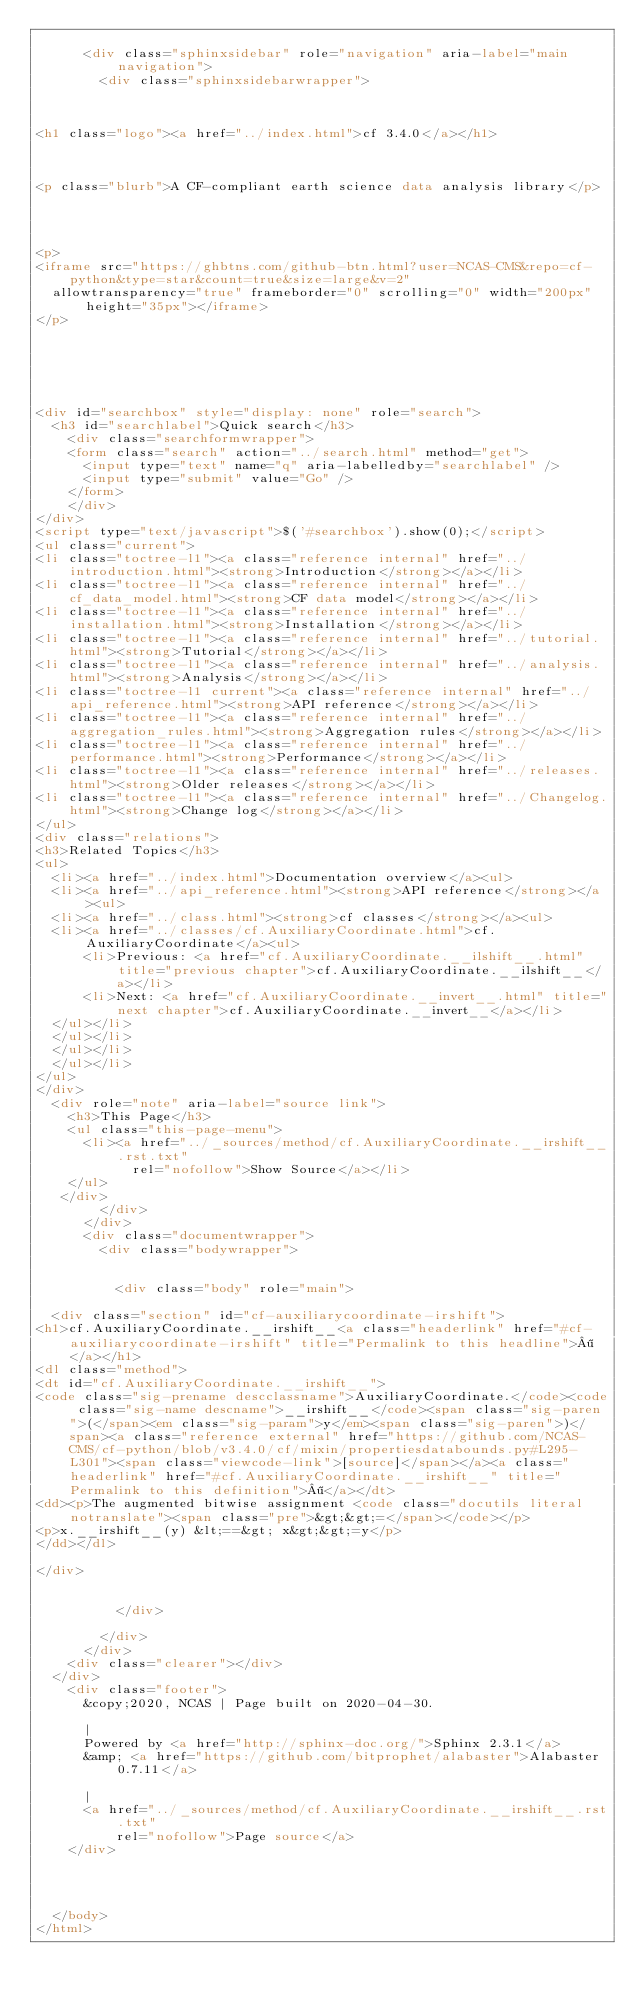Convert code to text. <code><loc_0><loc_0><loc_500><loc_500><_HTML_>    
      <div class="sphinxsidebar" role="navigation" aria-label="main navigation">
        <div class="sphinxsidebarwrapper">



<h1 class="logo"><a href="../index.html">cf 3.4.0</a></h1>



<p class="blurb">A CF-compliant earth science data analysis library</p>




<p>
<iframe src="https://ghbtns.com/github-btn.html?user=NCAS-CMS&repo=cf-python&type=star&count=true&size=large&v=2"
  allowtransparency="true" frameborder="0" scrolling="0" width="200px" height="35px"></iframe>
</p>






<div id="searchbox" style="display: none" role="search">
  <h3 id="searchlabel">Quick search</h3>
    <div class="searchformwrapper">
    <form class="search" action="../search.html" method="get">
      <input type="text" name="q" aria-labelledby="searchlabel" />
      <input type="submit" value="Go" />
    </form>
    </div>
</div>
<script type="text/javascript">$('#searchbox').show(0);</script>
<ul class="current">
<li class="toctree-l1"><a class="reference internal" href="../introduction.html"><strong>Introduction</strong></a></li>
<li class="toctree-l1"><a class="reference internal" href="../cf_data_model.html"><strong>CF data model</strong></a></li>
<li class="toctree-l1"><a class="reference internal" href="../installation.html"><strong>Installation</strong></a></li>
<li class="toctree-l1"><a class="reference internal" href="../tutorial.html"><strong>Tutorial</strong></a></li>
<li class="toctree-l1"><a class="reference internal" href="../analysis.html"><strong>Analysis</strong></a></li>
<li class="toctree-l1 current"><a class="reference internal" href="../api_reference.html"><strong>API reference</strong></a></li>
<li class="toctree-l1"><a class="reference internal" href="../aggregation_rules.html"><strong>Aggregation rules</strong></a></li>
<li class="toctree-l1"><a class="reference internal" href="../performance.html"><strong>Performance</strong></a></li>
<li class="toctree-l1"><a class="reference internal" href="../releases.html"><strong>Older releases</strong></a></li>
<li class="toctree-l1"><a class="reference internal" href="../Changelog.html"><strong>Change log</strong></a></li>
</ul>
<div class="relations">
<h3>Related Topics</h3>
<ul>
  <li><a href="../index.html">Documentation overview</a><ul>
  <li><a href="../api_reference.html"><strong>API reference</strong></a><ul>
  <li><a href="../class.html"><strong>cf classes</strong></a><ul>
  <li><a href="../classes/cf.AuxiliaryCoordinate.html">cf.AuxiliaryCoordinate</a><ul>
      <li>Previous: <a href="cf.AuxiliaryCoordinate.__ilshift__.html" title="previous chapter">cf.AuxiliaryCoordinate.__ilshift__</a></li>
      <li>Next: <a href="cf.AuxiliaryCoordinate.__invert__.html" title="next chapter">cf.AuxiliaryCoordinate.__invert__</a></li>
  </ul></li>
  </ul></li>
  </ul></li>
  </ul></li>
</ul>
</div>
  <div role="note" aria-label="source link">
    <h3>This Page</h3>
    <ul class="this-page-menu">
      <li><a href="../_sources/method/cf.AuxiliaryCoordinate.__irshift__.rst.txt"
            rel="nofollow">Show Source</a></li>
    </ul>
   </div>
        </div>
      </div>
      <div class="documentwrapper">
        <div class="bodywrapper">
          

          <div class="body" role="main">
            
  <div class="section" id="cf-auxiliarycoordinate-irshift">
<h1>cf.AuxiliaryCoordinate.__irshift__<a class="headerlink" href="#cf-auxiliarycoordinate-irshift" title="Permalink to this headline">¶</a></h1>
<dl class="method">
<dt id="cf.AuxiliaryCoordinate.__irshift__">
<code class="sig-prename descclassname">AuxiliaryCoordinate.</code><code class="sig-name descname">__irshift__</code><span class="sig-paren">(</span><em class="sig-param">y</em><span class="sig-paren">)</span><a class="reference external" href="https://github.com/NCAS-CMS/cf-python/blob/v3.4.0/cf/mixin/propertiesdatabounds.py#L295-L301"><span class="viewcode-link">[source]</span></a><a class="headerlink" href="#cf.AuxiliaryCoordinate.__irshift__" title="Permalink to this definition">¶</a></dt>
<dd><p>The augmented bitwise assignment <code class="docutils literal notranslate"><span class="pre">&gt;&gt;=</span></code></p>
<p>x.__irshift__(y) &lt;==&gt; x&gt;&gt;=y</p>
</dd></dl>

</div>


          </div>
          
        </div>
      </div>
    <div class="clearer"></div>
  </div>
    <div class="footer">
      &copy;2020, NCAS | Page built on 2020-04-30.
      
      |
      Powered by <a href="http://sphinx-doc.org/">Sphinx 2.3.1</a>
      &amp; <a href="https://github.com/bitprophet/alabaster">Alabaster 0.7.11</a>
      
      |
      <a href="../_sources/method/cf.AuxiliaryCoordinate.__irshift__.rst.txt"
          rel="nofollow">Page source</a>
    </div>

    

    
  </body>
</html></code> 